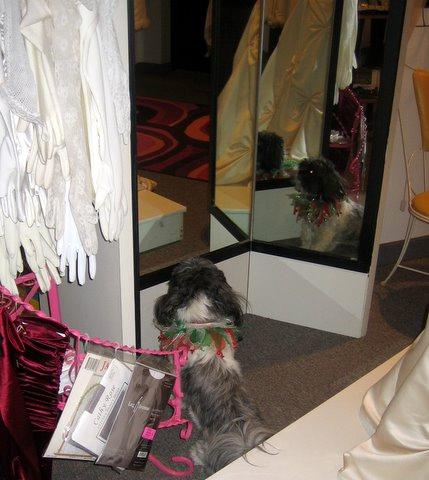Question: what is to the left of the mirror?
Choices:
A. Jewelry.
B. Towels.
C. Long white gloves.
D. Toiletries.
Answer with the letter. Answer: C Question: what is on the far right, to the left of the mirror?
Choices:
A. A green sofa.
B. A red table.
C. A purple pillow.
D. A yellow chair.
Answer with the letter. Answer: D Question: who is looking at this scene?
Choices:
A. The handyman.
B. The contractor.
C. The newlywed.
D. The photographer.
Answer with the letter. Answer: D Question: where is the black border?
Choices:
A. Along the edge of the mirror.
B. On the bed ruffle.
C. At the bottom of the sofa.
D. On the throw rug.
Answer with the letter. Answer: A Question: how many sides of the mirror are visible?
Choices:
A. One.
B. Three.
C. Zero.
D. Two.
Answer with the letter. Answer: D 